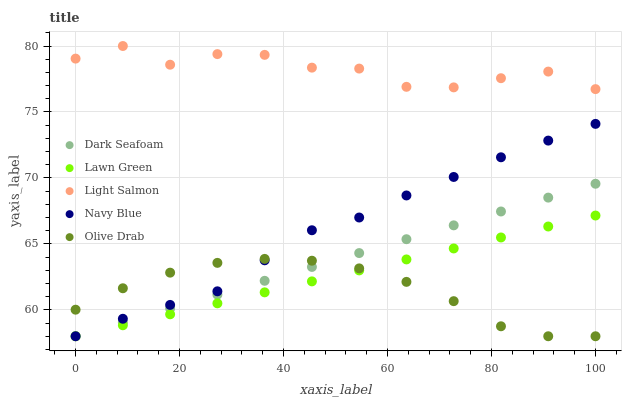Does Olive Drab have the minimum area under the curve?
Answer yes or no. Yes. Does Light Salmon have the maximum area under the curve?
Answer yes or no. Yes. Does Dark Seafoam have the minimum area under the curve?
Answer yes or no. No. Does Dark Seafoam have the maximum area under the curve?
Answer yes or no. No. Is Lawn Green the smoothest?
Answer yes or no. Yes. Is Light Salmon the roughest?
Answer yes or no. Yes. Is Dark Seafoam the smoothest?
Answer yes or no. No. Is Dark Seafoam the roughest?
Answer yes or no. No. Does Lawn Green have the lowest value?
Answer yes or no. Yes. Does Light Salmon have the lowest value?
Answer yes or no. No. Does Light Salmon have the highest value?
Answer yes or no. Yes. Does Dark Seafoam have the highest value?
Answer yes or no. No. Is Dark Seafoam less than Light Salmon?
Answer yes or no. Yes. Is Light Salmon greater than Dark Seafoam?
Answer yes or no. Yes. Does Olive Drab intersect Dark Seafoam?
Answer yes or no. Yes. Is Olive Drab less than Dark Seafoam?
Answer yes or no. No. Is Olive Drab greater than Dark Seafoam?
Answer yes or no. No. Does Dark Seafoam intersect Light Salmon?
Answer yes or no. No. 